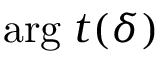Convert formula to latex. <formula><loc_0><loc_0><loc_500><loc_500>\arg \, t ( \delta )</formula> 